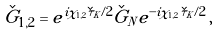<formula> <loc_0><loc_0><loc_500><loc_500>\check { G } _ { 1 , 2 } = e ^ { i \chi _ { 1 , 2 } \check { \tau } _ { K } / 2 } \check { G } _ { N } e ^ { - i \chi _ { 1 , 2 } \check { \tau } _ { K } / 2 } \, ,</formula> 